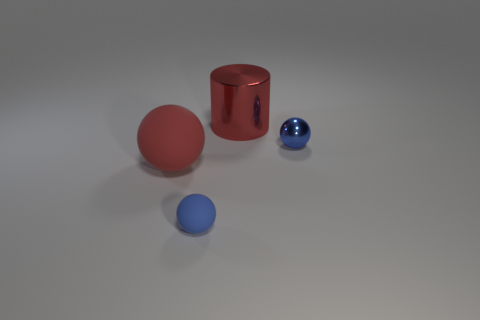What can you say about the lighting in the scene? The lighting in the scene appears to be soft and diffused, coming from above, with subtle shadows cast by the objects indicating a light source positioned towards the front of the objects. 